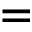Convert formula to latex. <formula><loc_0><loc_0><loc_500><loc_500>=</formula> 